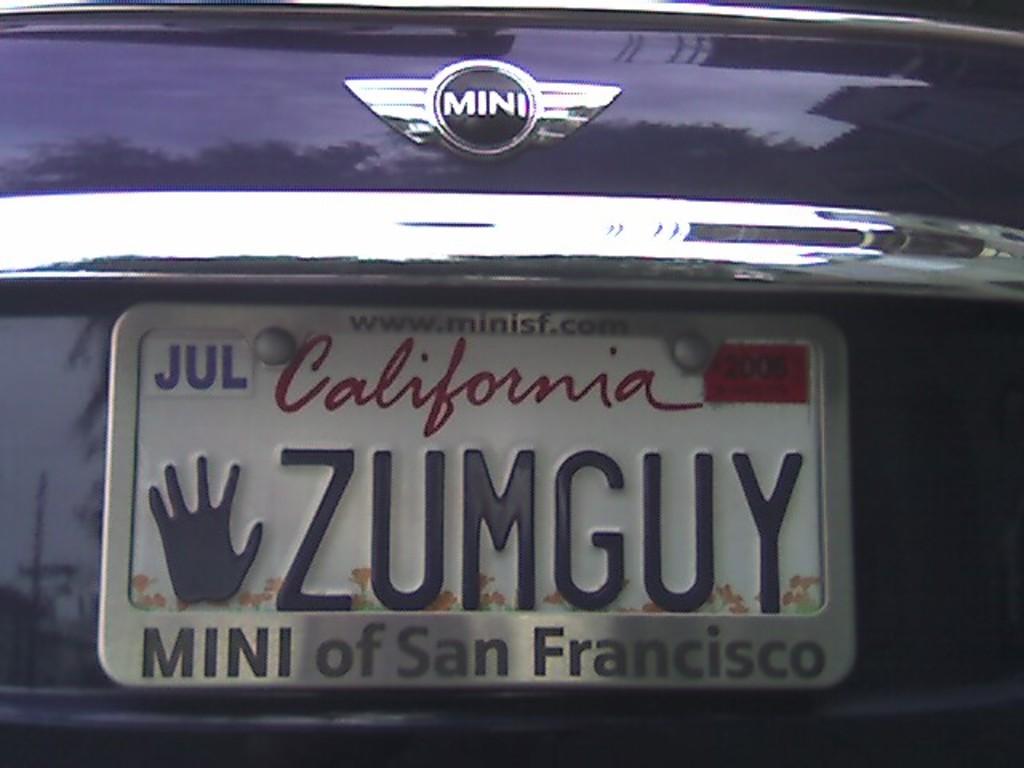What state is the plate from?
Provide a short and direct response. California. What is the web address on the plate frame?
Your answer should be compact. Www.minisf.com. 